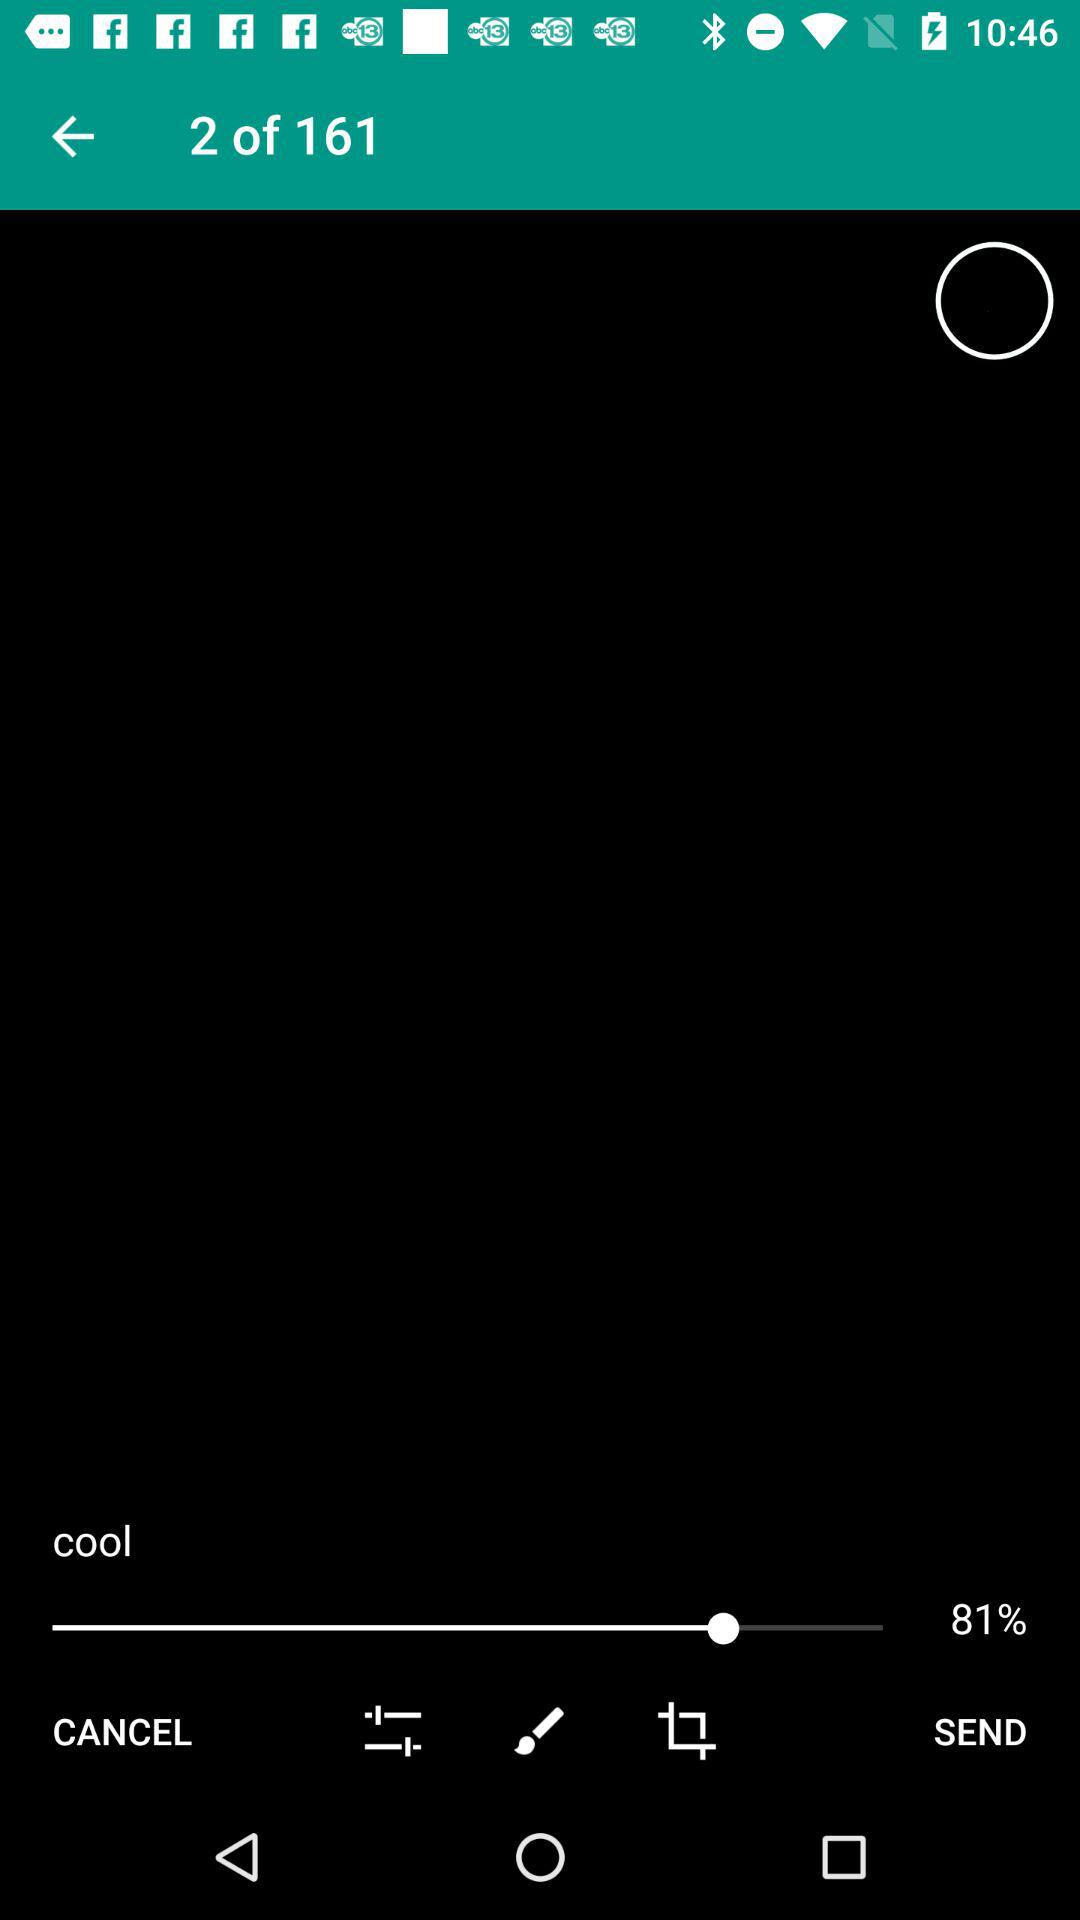How many sets are available? There are 161 sets available. 